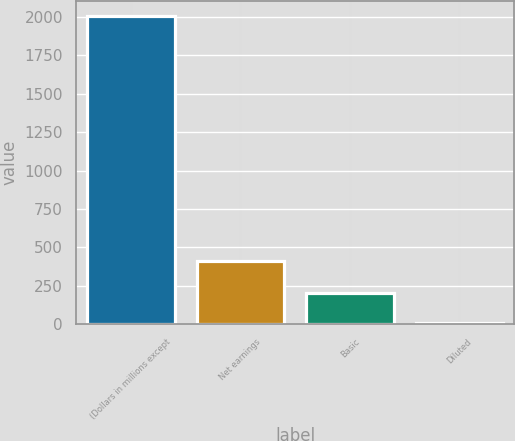Convert chart. <chart><loc_0><loc_0><loc_500><loc_500><bar_chart><fcel>(Dollars in millions except<fcel>Net earnings<fcel>Basic<fcel>Diluted<nl><fcel>2006<fcel>409<fcel>205.02<fcel>4.91<nl></chart> 